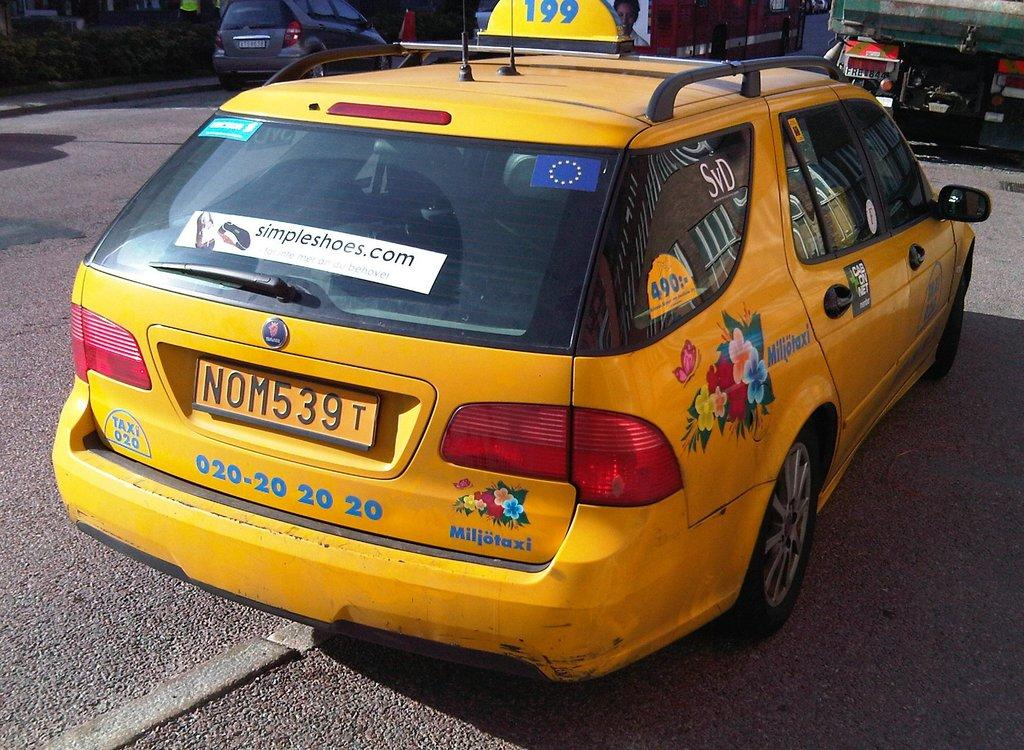What type of vehicles can be seen on the road in the image? There are cars on the road in the image. What can be seen in the distance behind the cars? There are buildings in the background of the image. What type of vegetation is visible at the top of the image? There are plants visible at the top of the image. Can you describe the person in the image? There is a person in the image, but no specific details about the person are provided. What type of wood is used to make the cushion in the image? There is no wood or cushion present in the image. 